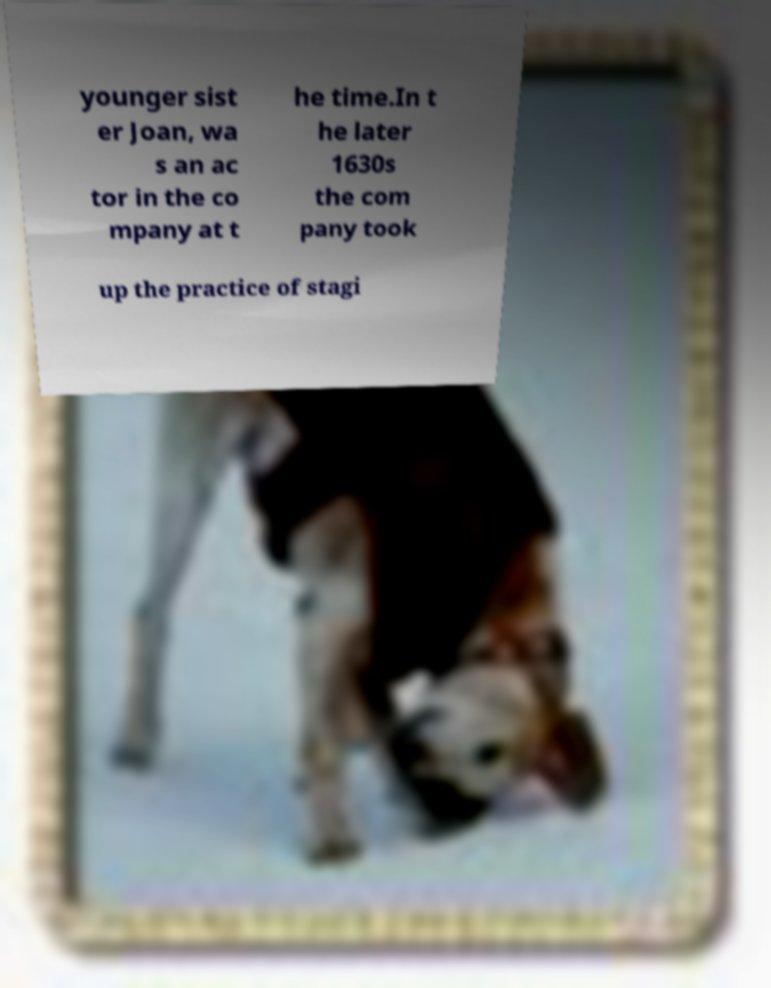Can you accurately transcribe the text from the provided image for me? younger sist er Joan, wa s an ac tor in the co mpany at t he time.In t he later 1630s the com pany took up the practice of stagi 